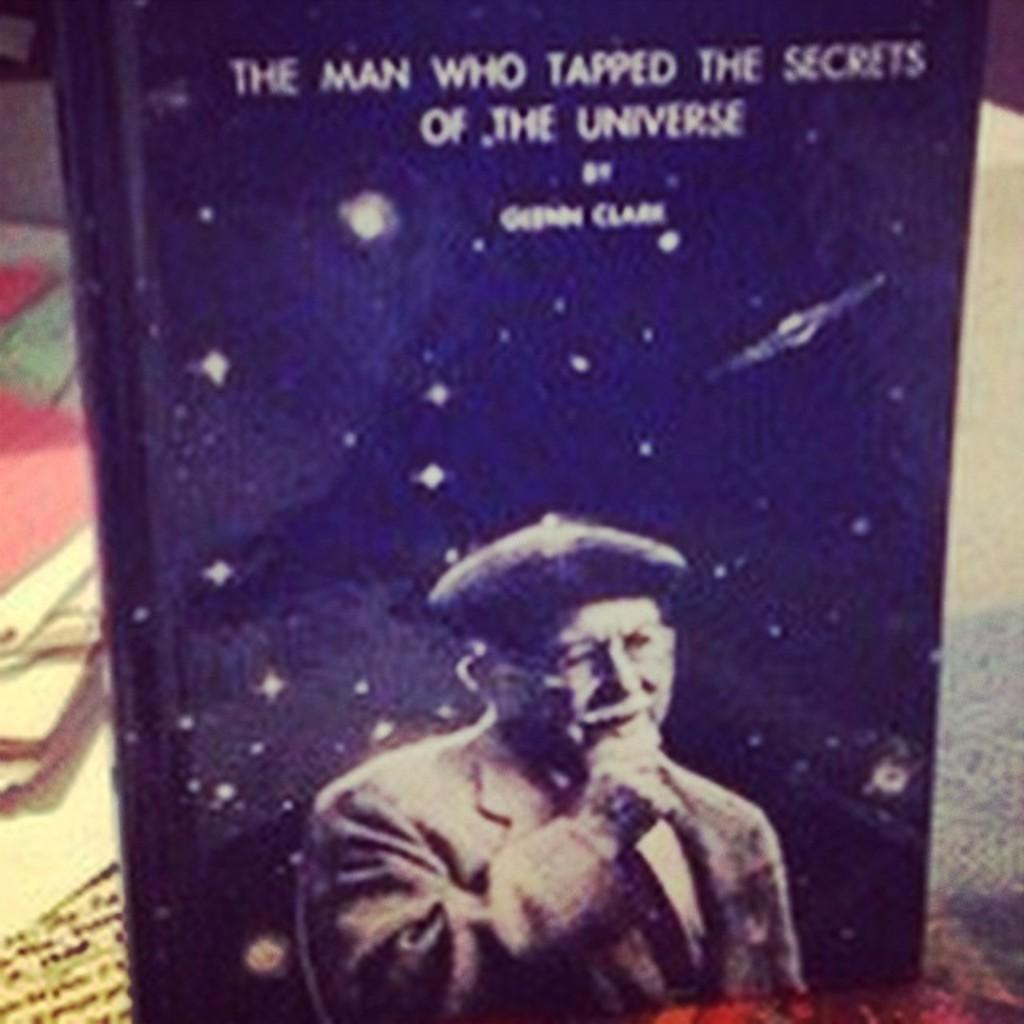<image>
Write a terse but informative summary of the picture. A book titled The Man Who Tapped The Secrets Of The Universe. 